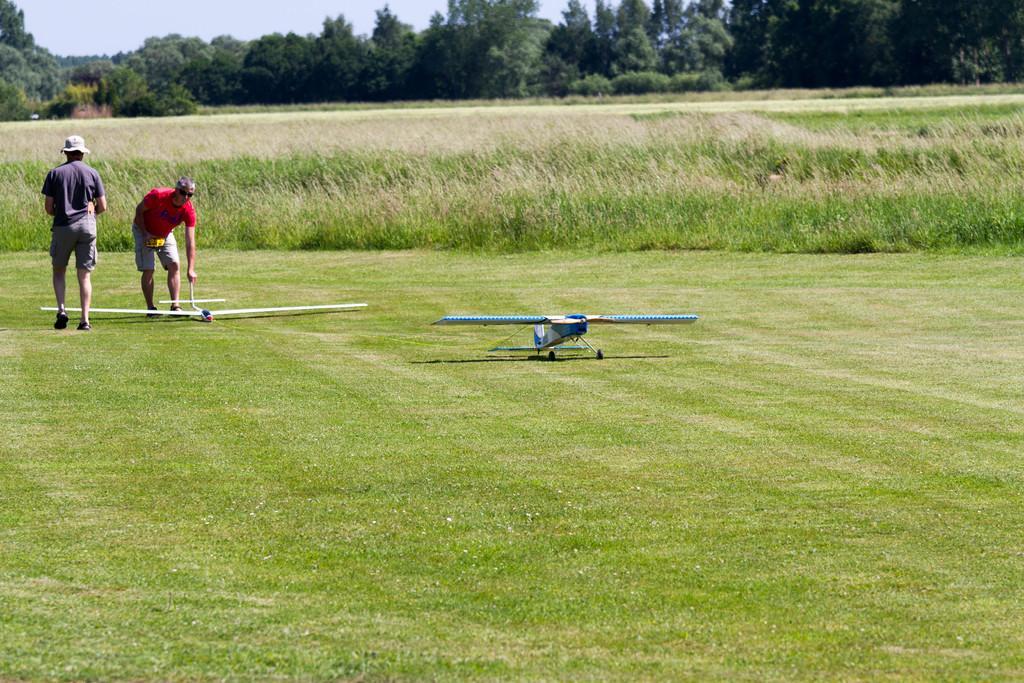Describe this image in one or two sentences. In this image we can see two people, planes, grass, and plants. In the background there are trees and sky. 